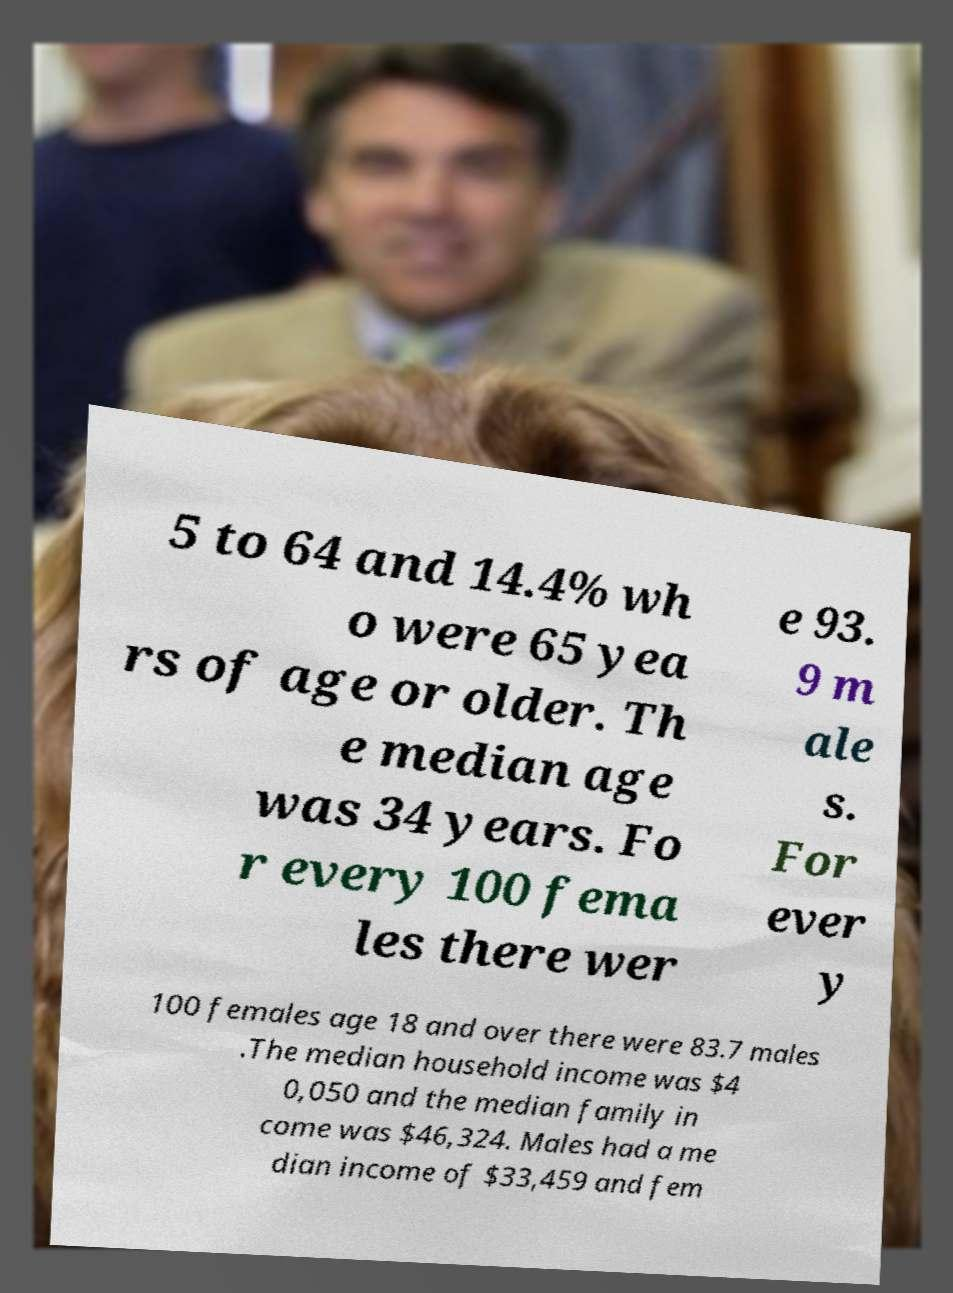Could you extract and type out the text from this image? 5 to 64 and 14.4% wh o were 65 yea rs of age or older. Th e median age was 34 years. Fo r every 100 fema les there wer e 93. 9 m ale s. For ever y 100 females age 18 and over there were 83.7 males .The median household income was $4 0,050 and the median family in come was $46,324. Males had a me dian income of $33,459 and fem 